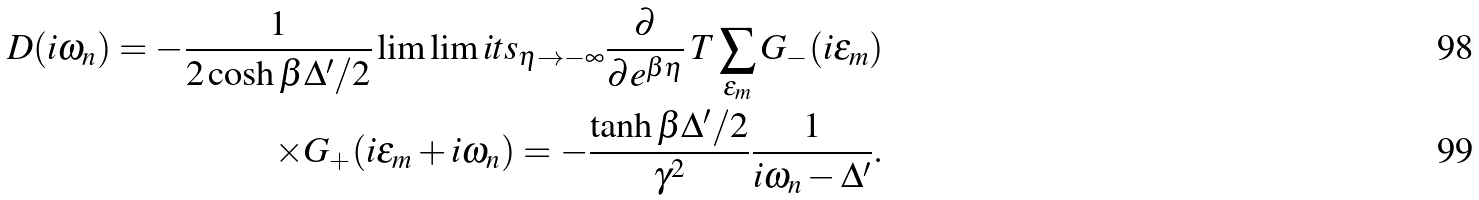<formula> <loc_0><loc_0><loc_500><loc_500>D ( i \omega _ { n } ) = - \frac { 1 } { 2 \cosh \beta \Delta ^ { \prime } / 2 } \lim \lim i t s _ { \eta \to - \infty } \frac { \partial } { \partial e ^ { \beta \eta } } \, T \sum _ { \epsilon _ { m } } G _ { - } ( i \epsilon _ { m } ) \\ \times G _ { + } ( i \epsilon _ { m } + i \omega _ { n } ) = - \frac { \tanh \beta \Delta ^ { \prime } / 2 } { \gamma ^ { 2 } } \frac { 1 } { i \omega _ { n } - \Delta ^ { \prime } } .</formula> 